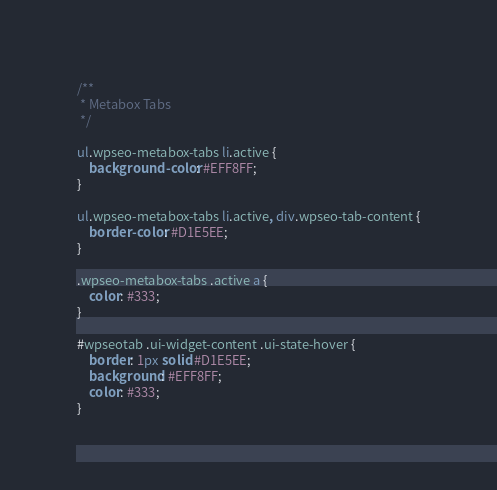Convert code to text. <code><loc_0><loc_0><loc_500><loc_500><_CSS_>/**
 * Metabox Tabs
 */

ul.wpseo-metabox-tabs li.active {
	background-color: #EFF8FF;
}

ul.wpseo-metabox-tabs li.active, div.wpseo-tab-content {
	border-color: #D1E5EE;
}

.wpseo-metabox-tabs .active a {
	color: #333;
}

#wpseotab .ui-widget-content .ui-state-hover {
	border: 1px solid #D1E5EE;
	background: #EFF8FF;
	color: #333;
}</code> 